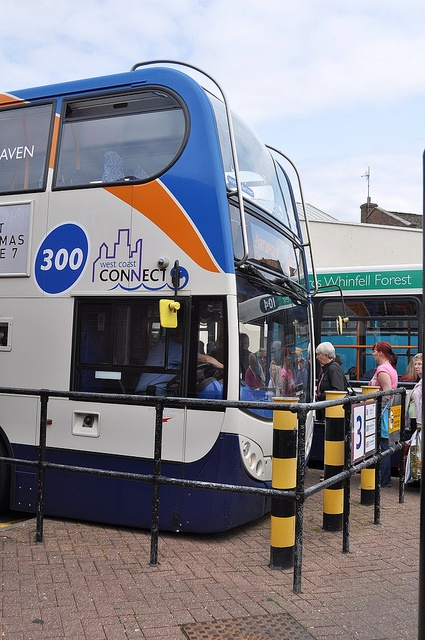Describe the objects in this image and their specific colors. I can see bus in lavender, black, darkgray, lightgray, and gray tones, bus in lavender, black, gray, teal, and lightgray tones, people in lavender, black, gray, lightgray, and darkgray tones, people in lavender, black, gray, and darkblue tones, and people in lavender, darkgray, gray, and black tones in this image. 